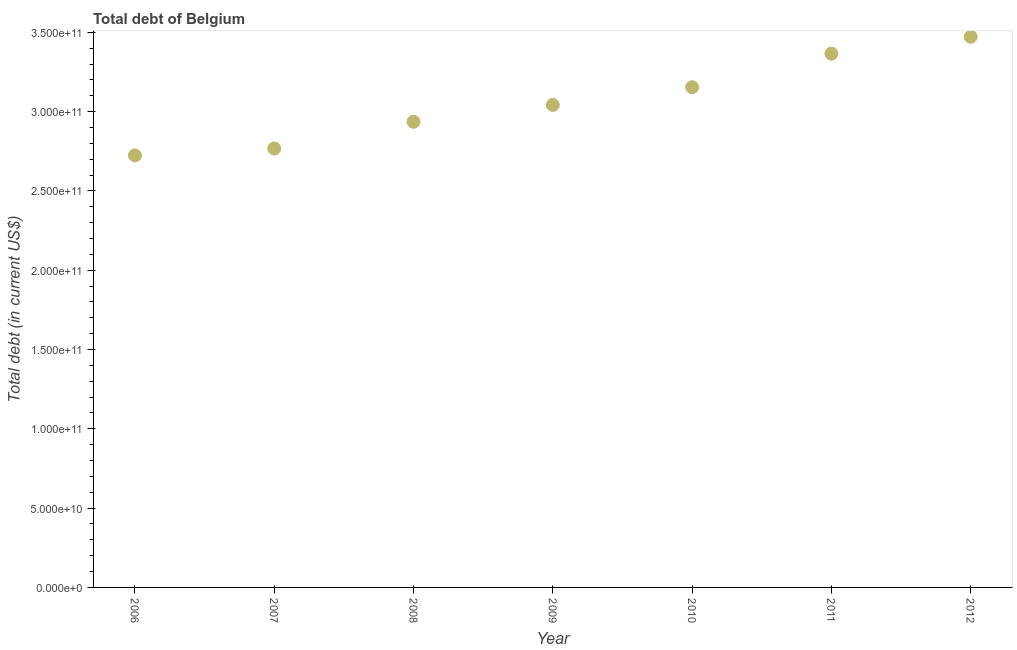What is the total debt in 2006?
Your response must be concise. 2.72e+11. Across all years, what is the maximum total debt?
Your answer should be very brief. 3.47e+11. Across all years, what is the minimum total debt?
Make the answer very short. 2.72e+11. In which year was the total debt maximum?
Your answer should be very brief. 2012. What is the sum of the total debt?
Make the answer very short. 2.15e+12. What is the difference between the total debt in 2006 and 2011?
Ensure brevity in your answer.  -6.41e+1. What is the average total debt per year?
Your response must be concise. 3.07e+11. What is the median total debt?
Keep it short and to the point. 3.04e+11. What is the ratio of the total debt in 2009 to that in 2011?
Ensure brevity in your answer.  0.9. Is the difference between the total debt in 2011 and 2012 greater than the difference between any two years?
Offer a terse response. No. What is the difference between the highest and the second highest total debt?
Make the answer very short. 1.07e+1. What is the difference between the highest and the lowest total debt?
Ensure brevity in your answer.  7.48e+1. How many years are there in the graph?
Keep it short and to the point. 7. Are the values on the major ticks of Y-axis written in scientific E-notation?
Make the answer very short. Yes. Does the graph contain any zero values?
Your answer should be compact. No. Does the graph contain grids?
Your answer should be compact. No. What is the title of the graph?
Provide a succinct answer. Total debt of Belgium. What is the label or title of the X-axis?
Your answer should be very brief. Year. What is the label or title of the Y-axis?
Ensure brevity in your answer.  Total debt (in current US$). What is the Total debt (in current US$) in 2006?
Keep it short and to the point. 2.72e+11. What is the Total debt (in current US$) in 2007?
Make the answer very short. 2.77e+11. What is the Total debt (in current US$) in 2008?
Give a very brief answer. 2.94e+11. What is the Total debt (in current US$) in 2009?
Provide a short and direct response. 3.04e+11. What is the Total debt (in current US$) in 2010?
Your answer should be very brief. 3.15e+11. What is the Total debt (in current US$) in 2011?
Make the answer very short. 3.37e+11. What is the Total debt (in current US$) in 2012?
Ensure brevity in your answer.  3.47e+11. What is the difference between the Total debt (in current US$) in 2006 and 2007?
Your response must be concise. -4.37e+09. What is the difference between the Total debt (in current US$) in 2006 and 2008?
Keep it short and to the point. -2.12e+1. What is the difference between the Total debt (in current US$) in 2006 and 2009?
Provide a short and direct response. -3.18e+1. What is the difference between the Total debt (in current US$) in 2006 and 2010?
Keep it short and to the point. -4.30e+1. What is the difference between the Total debt (in current US$) in 2006 and 2011?
Offer a very short reply. -6.41e+1. What is the difference between the Total debt (in current US$) in 2006 and 2012?
Your answer should be compact. -7.48e+1. What is the difference between the Total debt (in current US$) in 2007 and 2008?
Offer a very short reply. -1.69e+1. What is the difference between the Total debt (in current US$) in 2007 and 2009?
Your answer should be very brief. -2.75e+1. What is the difference between the Total debt (in current US$) in 2007 and 2010?
Provide a short and direct response. -3.86e+1. What is the difference between the Total debt (in current US$) in 2007 and 2011?
Ensure brevity in your answer.  -5.98e+1. What is the difference between the Total debt (in current US$) in 2007 and 2012?
Offer a very short reply. -7.05e+1. What is the difference between the Total debt (in current US$) in 2008 and 2009?
Provide a succinct answer. -1.06e+1. What is the difference between the Total debt (in current US$) in 2008 and 2010?
Your answer should be very brief. -2.18e+1. What is the difference between the Total debt (in current US$) in 2008 and 2011?
Ensure brevity in your answer.  -4.29e+1. What is the difference between the Total debt (in current US$) in 2008 and 2012?
Offer a very short reply. -5.36e+1. What is the difference between the Total debt (in current US$) in 2009 and 2010?
Provide a succinct answer. -1.12e+1. What is the difference between the Total debt (in current US$) in 2009 and 2011?
Your answer should be very brief. -3.23e+1. What is the difference between the Total debt (in current US$) in 2009 and 2012?
Provide a short and direct response. -4.30e+1. What is the difference between the Total debt (in current US$) in 2010 and 2011?
Offer a very short reply. -2.11e+1. What is the difference between the Total debt (in current US$) in 2010 and 2012?
Offer a terse response. -3.18e+1. What is the difference between the Total debt (in current US$) in 2011 and 2012?
Offer a terse response. -1.07e+1. What is the ratio of the Total debt (in current US$) in 2006 to that in 2007?
Provide a succinct answer. 0.98. What is the ratio of the Total debt (in current US$) in 2006 to that in 2008?
Your answer should be compact. 0.93. What is the ratio of the Total debt (in current US$) in 2006 to that in 2009?
Provide a short and direct response. 0.9. What is the ratio of the Total debt (in current US$) in 2006 to that in 2010?
Ensure brevity in your answer.  0.86. What is the ratio of the Total debt (in current US$) in 2006 to that in 2011?
Give a very brief answer. 0.81. What is the ratio of the Total debt (in current US$) in 2006 to that in 2012?
Ensure brevity in your answer.  0.79. What is the ratio of the Total debt (in current US$) in 2007 to that in 2008?
Provide a succinct answer. 0.94. What is the ratio of the Total debt (in current US$) in 2007 to that in 2009?
Give a very brief answer. 0.91. What is the ratio of the Total debt (in current US$) in 2007 to that in 2010?
Your answer should be very brief. 0.88. What is the ratio of the Total debt (in current US$) in 2007 to that in 2011?
Keep it short and to the point. 0.82. What is the ratio of the Total debt (in current US$) in 2007 to that in 2012?
Give a very brief answer. 0.8. What is the ratio of the Total debt (in current US$) in 2008 to that in 2009?
Ensure brevity in your answer.  0.96. What is the ratio of the Total debt (in current US$) in 2008 to that in 2011?
Offer a terse response. 0.87. What is the ratio of the Total debt (in current US$) in 2008 to that in 2012?
Make the answer very short. 0.85. What is the ratio of the Total debt (in current US$) in 2009 to that in 2011?
Your answer should be compact. 0.9. What is the ratio of the Total debt (in current US$) in 2009 to that in 2012?
Offer a very short reply. 0.88. What is the ratio of the Total debt (in current US$) in 2010 to that in 2011?
Provide a succinct answer. 0.94. What is the ratio of the Total debt (in current US$) in 2010 to that in 2012?
Make the answer very short. 0.91. What is the ratio of the Total debt (in current US$) in 2011 to that in 2012?
Keep it short and to the point. 0.97. 